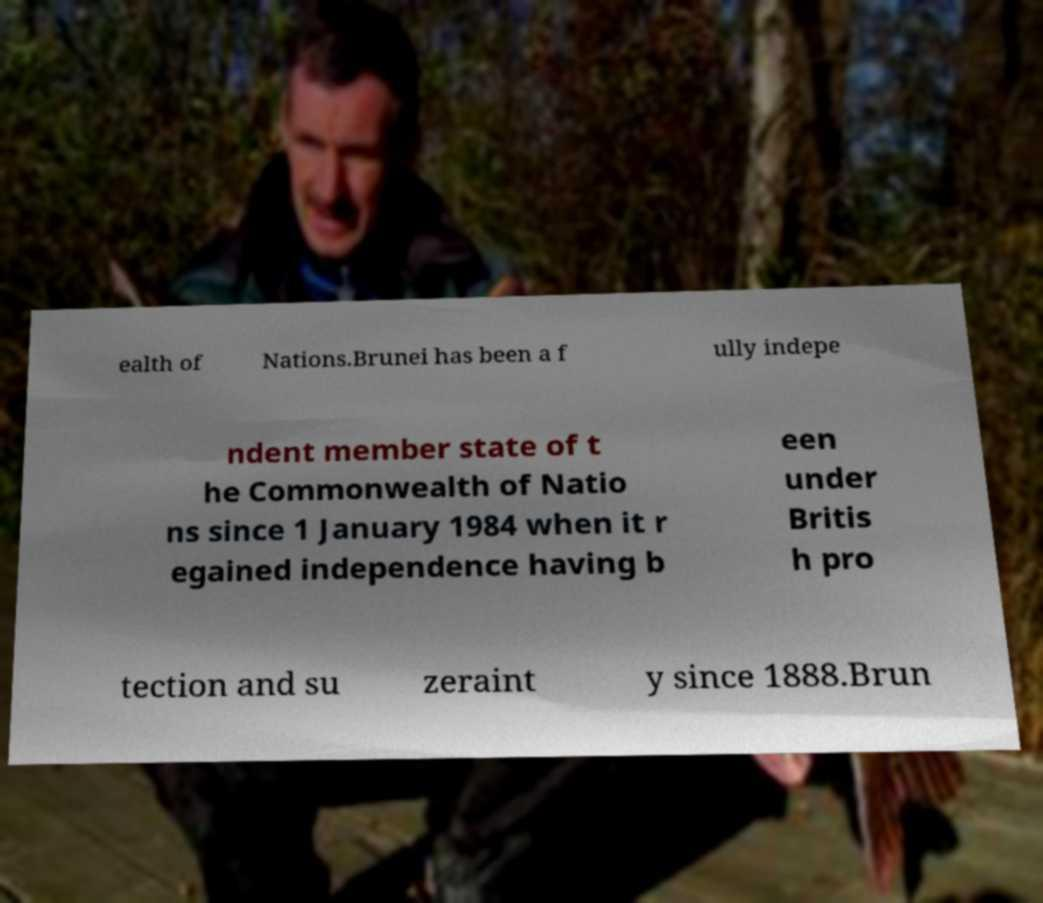There's text embedded in this image that I need extracted. Can you transcribe it verbatim? ealth of Nations.Brunei has been a f ully indepe ndent member state of t he Commonwealth of Natio ns since 1 January 1984 when it r egained independence having b een under Britis h pro tection and su zeraint y since 1888.Brun 